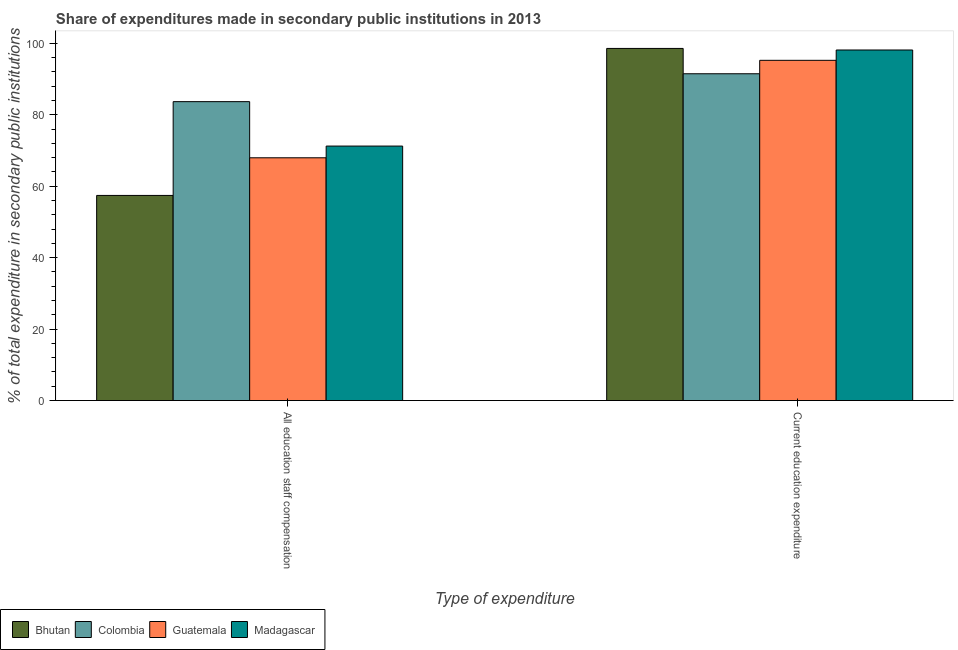How many different coloured bars are there?
Make the answer very short. 4. Are the number of bars per tick equal to the number of legend labels?
Keep it short and to the point. Yes. Are the number of bars on each tick of the X-axis equal?
Provide a succinct answer. Yes. How many bars are there on the 2nd tick from the right?
Provide a succinct answer. 4. What is the label of the 2nd group of bars from the left?
Provide a succinct answer. Current education expenditure. What is the expenditure in staff compensation in Madagascar?
Offer a terse response. 71.24. Across all countries, what is the maximum expenditure in education?
Your answer should be very brief. 98.58. Across all countries, what is the minimum expenditure in staff compensation?
Ensure brevity in your answer.  57.43. What is the total expenditure in education in the graph?
Ensure brevity in your answer.  383.44. What is the difference between the expenditure in staff compensation in Madagascar and that in Guatemala?
Your answer should be very brief. 3.28. What is the difference between the expenditure in staff compensation in Guatemala and the expenditure in education in Madagascar?
Ensure brevity in your answer.  -30.17. What is the average expenditure in education per country?
Your answer should be very brief. 95.86. What is the difference between the expenditure in education and expenditure in staff compensation in Colombia?
Provide a short and direct response. 7.81. In how many countries, is the expenditure in education greater than 16 %?
Keep it short and to the point. 4. What is the ratio of the expenditure in education in Colombia to that in Bhutan?
Your response must be concise. 0.93. Is the expenditure in staff compensation in Bhutan less than that in Guatemala?
Ensure brevity in your answer.  Yes. What does the 1st bar from the left in Current education expenditure represents?
Provide a short and direct response. Bhutan. What does the 1st bar from the right in Current education expenditure represents?
Offer a very short reply. Madagascar. How many countries are there in the graph?
Offer a very short reply. 4. What is the difference between two consecutive major ticks on the Y-axis?
Offer a terse response. 20. Are the values on the major ticks of Y-axis written in scientific E-notation?
Make the answer very short. No. Does the graph contain any zero values?
Offer a very short reply. No. Does the graph contain grids?
Your answer should be very brief. No. What is the title of the graph?
Offer a terse response. Share of expenditures made in secondary public institutions in 2013. Does "Ireland" appear as one of the legend labels in the graph?
Give a very brief answer. No. What is the label or title of the X-axis?
Offer a very short reply. Type of expenditure. What is the label or title of the Y-axis?
Your answer should be very brief. % of total expenditure in secondary public institutions. What is the % of total expenditure in secondary public institutions of Bhutan in All education staff compensation?
Give a very brief answer. 57.43. What is the % of total expenditure in secondary public institutions in Colombia in All education staff compensation?
Provide a short and direct response. 83.68. What is the % of total expenditure in secondary public institutions of Guatemala in All education staff compensation?
Make the answer very short. 67.96. What is the % of total expenditure in secondary public institutions in Madagascar in All education staff compensation?
Provide a short and direct response. 71.24. What is the % of total expenditure in secondary public institutions of Bhutan in Current education expenditure?
Keep it short and to the point. 98.58. What is the % of total expenditure in secondary public institutions in Colombia in Current education expenditure?
Offer a very short reply. 91.49. What is the % of total expenditure in secondary public institutions in Guatemala in Current education expenditure?
Give a very brief answer. 95.25. What is the % of total expenditure in secondary public institutions of Madagascar in Current education expenditure?
Make the answer very short. 98.14. Across all Type of expenditure, what is the maximum % of total expenditure in secondary public institutions of Bhutan?
Offer a terse response. 98.58. Across all Type of expenditure, what is the maximum % of total expenditure in secondary public institutions of Colombia?
Your answer should be very brief. 91.49. Across all Type of expenditure, what is the maximum % of total expenditure in secondary public institutions in Guatemala?
Provide a short and direct response. 95.25. Across all Type of expenditure, what is the maximum % of total expenditure in secondary public institutions of Madagascar?
Offer a terse response. 98.14. Across all Type of expenditure, what is the minimum % of total expenditure in secondary public institutions of Bhutan?
Provide a short and direct response. 57.43. Across all Type of expenditure, what is the minimum % of total expenditure in secondary public institutions in Colombia?
Offer a terse response. 83.68. Across all Type of expenditure, what is the minimum % of total expenditure in secondary public institutions of Guatemala?
Your answer should be very brief. 67.96. Across all Type of expenditure, what is the minimum % of total expenditure in secondary public institutions of Madagascar?
Give a very brief answer. 71.24. What is the total % of total expenditure in secondary public institutions of Bhutan in the graph?
Your answer should be compact. 156. What is the total % of total expenditure in secondary public institutions in Colombia in the graph?
Provide a succinct answer. 175.16. What is the total % of total expenditure in secondary public institutions of Guatemala in the graph?
Provide a succinct answer. 163.21. What is the total % of total expenditure in secondary public institutions in Madagascar in the graph?
Offer a very short reply. 169.38. What is the difference between the % of total expenditure in secondary public institutions of Bhutan in All education staff compensation and that in Current education expenditure?
Give a very brief answer. -41.15. What is the difference between the % of total expenditure in secondary public institutions of Colombia in All education staff compensation and that in Current education expenditure?
Make the answer very short. -7.81. What is the difference between the % of total expenditure in secondary public institutions in Guatemala in All education staff compensation and that in Current education expenditure?
Your answer should be compact. -27.28. What is the difference between the % of total expenditure in secondary public institutions of Madagascar in All education staff compensation and that in Current education expenditure?
Provide a short and direct response. -26.89. What is the difference between the % of total expenditure in secondary public institutions of Bhutan in All education staff compensation and the % of total expenditure in secondary public institutions of Colombia in Current education expenditure?
Provide a succinct answer. -34.06. What is the difference between the % of total expenditure in secondary public institutions in Bhutan in All education staff compensation and the % of total expenditure in secondary public institutions in Guatemala in Current education expenditure?
Provide a short and direct response. -37.82. What is the difference between the % of total expenditure in secondary public institutions of Bhutan in All education staff compensation and the % of total expenditure in secondary public institutions of Madagascar in Current education expenditure?
Offer a terse response. -40.71. What is the difference between the % of total expenditure in secondary public institutions of Colombia in All education staff compensation and the % of total expenditure in secondary public institutions of Guatemala in Current education expenditure?
Provide a succinct answer. -11.57. What is the difference between the % of total expenditure in secondary public institutions in Colombia in All education staff compensation and the % of total expenditure in secondary public institutions in Madagascar in Current education expenditure?
Offer a terse response. -14.46. What is the difference between the % of total expenditure in secondary public institutions of Guatemala in All education staff compensation and the % of total expenditure in secondary public institutions of Madagascar in Current education expenditure?
Ensure brevity in your answer.  -30.17. What is the average % of total expenditure in secondary public institutions of Bhutan per Type of expenditure?
Make the answer very short. 78. What is the average % of total expenditure in secondary public institutions in Colombia per Type of expenditure?
Your answer should be compact. 87.58. What is the average % of total expenditure in secondary public institutions in Guatemala per Type of expenditure?
Provide a succinct answer. 81.61. What is the average % of total expenditure in secondary public institutions of Madagascar per Type of expenditure?
Provide a short and direct response. 84.69. What is the difference between the % of total expenditure in secondary public institutions of Bhutan and % of total expenditure in secondary public institutions of Colombia in All education staff compensation?
Your answer should be very brief. -26.25. What is the difference between the % of total expenditure in secondary public institutions in Bhutan and % of total expenditure in secondary public institutions in Guatemala in All education staff compensation?
Give a very brief answer. -10.54. What is the difference between the % of total expenditure in secondary public institutions in Bhutan and % of total expenditure in secondary public institutions in Madagascar in All education staff compensation?
Offer a very short reply. -13.82. What is the difference between the % of total expenditure in secondary public institutions of Colombia and % of total expenditure in secondary public institutions of Guatemala in All education staff compensation?
Keep it short and to the point. 15.71. What is the difference between the % of total expenditure in secondary public institutions of Colombia and % of total expenditure in secondary public institutions of Madagascar in All education staff compensation?
Give a very brief answer. 12.44. What is the difference between the % of total expenditure in secondary public institutions in Guatemala and % of total expenditure in secondary public institutions in Madagascar in All education staff compensation?
Give a very brief answer. -3.28. What is the difference between the % of total expenditure in secondary public institutions of Bhutan and % of total expenditure in secondary public institutions of Colombia in Current education expenditure?
Your answer should be very brief. 7.09. What is the difference between the % of total expenditure in secondary public institutions of Bhutan and % of total expenditure in secondary public institutions of Guatemala in Current education expenditure?
Provide a succinct answer. 3.33. What is the difference between the % of total expenditure in secondary public institutions in Bhutan and % of total expenditure in secondary public institutions in Madagascar in Current education expenditure?
Give a very brief answer. 0.44. What is the difference between the % of total expenditure in secondary public institutions in Colombia and % of total expenditure in secondary public institutions in Guatemala in Current education expenditure?
Your answer should be very brief. -3.76. What is the difference between the % of total expenditure in secondary public institutions in Colombia and % of total expenditure in secondary public institutions in Madagascar in Current education expenditure?
Your response must be concise. -6.65. What is the difference between the % of total expenditure in secondary public institutions of Guatemala and % of total expenditure in secondary public institutions of Madagascar in Current education expenditure?
Provide a short and direct response. -2.89. What is the ratio of the % of total expenditure in secondary public institutions of Bhutan in All education staff compensation to that in Current education expenditure?
Keep it short and to the point. 0.58. What is the ratio of the % of total expenditure in secondary public institutions in Colombia in All education staff compensation to that in Current education expenditure?
Offer a very short reply. 0.91. What is the ratio of the % of total expenditure in secondary public institutions of Guatemala in All education staff compensation to that in Current education expenditure?
Ensure brevity in your answer.  0.71. What is the ratio of the % of total expenditure in secondary public institutions in Madagascar in All education staff compensation to that in Current education expenditure?
Your response must be concise. 0.73. What is the difference between the highest and the second highest % of total expenditure in secondary public institutions in Bhutan?
Provide a short and direct response. 41.15. What is the difference between the highest and the second highest % of total expenditure in secondary public institutions in Colombia?
Ensure brevity in your answer.  7.81. What is the difference between the highest and the second highest % of total expenditure in secondary public institutions in Guatemala?
Your response must be concise. 27.28. What is the difference between the highest and the second highest % of total expenditure in secondary public institutions of Madagascar?
Provide a succinct answer. 26.89. What is the difference between the highest and the lowest % of total expenditure in secondary public institutions of Bhutan?
Offer a terse response. 41.15. What is the difference between the highest and the lowest % of total expenditure in secondary public institutions of Colombia?
Your answer should be very brief. 7.81. What is the difference between the highest and the lowest % of total expenditure in secondary public institutions in Guatemala?
Give a very brief answer. 27.28. What is the difference between the highest and the lowest % of total expenditure in secondary public institutions of Madagascar?
Make the answer very short. 26.89. 